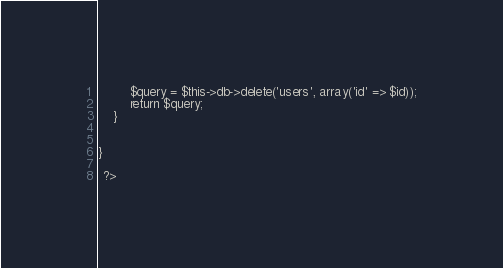Convert code to text. <code><loc_0><loc_0><loc_500><loc_500><_PHP_>		$query = $this->db->delete('users', array('id' => $id));
		return $query;
	}

	
}

 ?></code> 